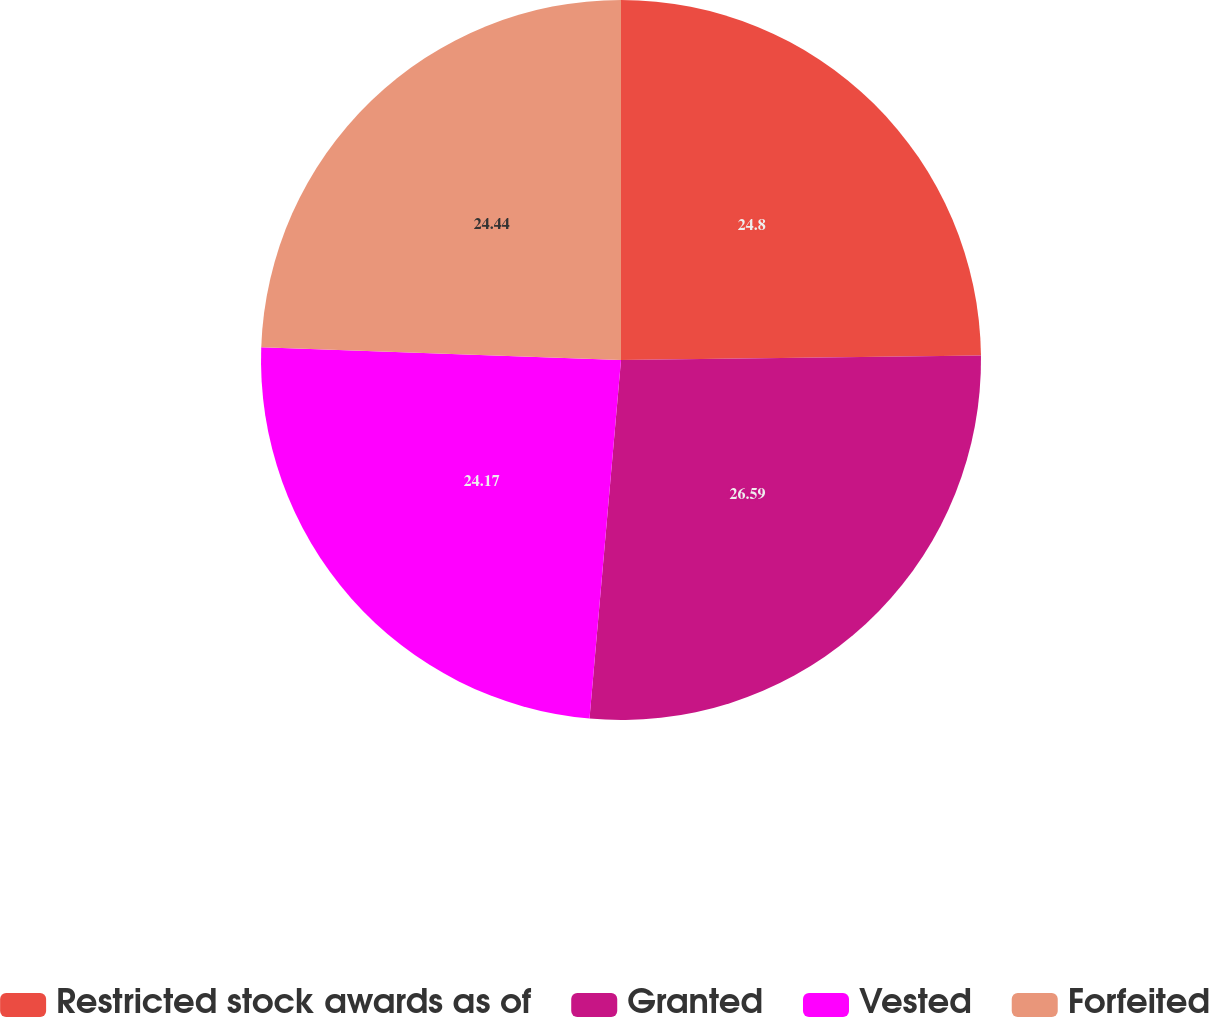Convert chart. <chart><loc_0><loc_0><loc_500><loc_500><pie_chart><fcel>Restricted stock awards as of<fcel>Granted<fcel>Vested<fcel>Forfeited<nl><fcel>24.8%<fcel>26.6%<fcel>24.17%<fcel>24.44%<nl></chart> 